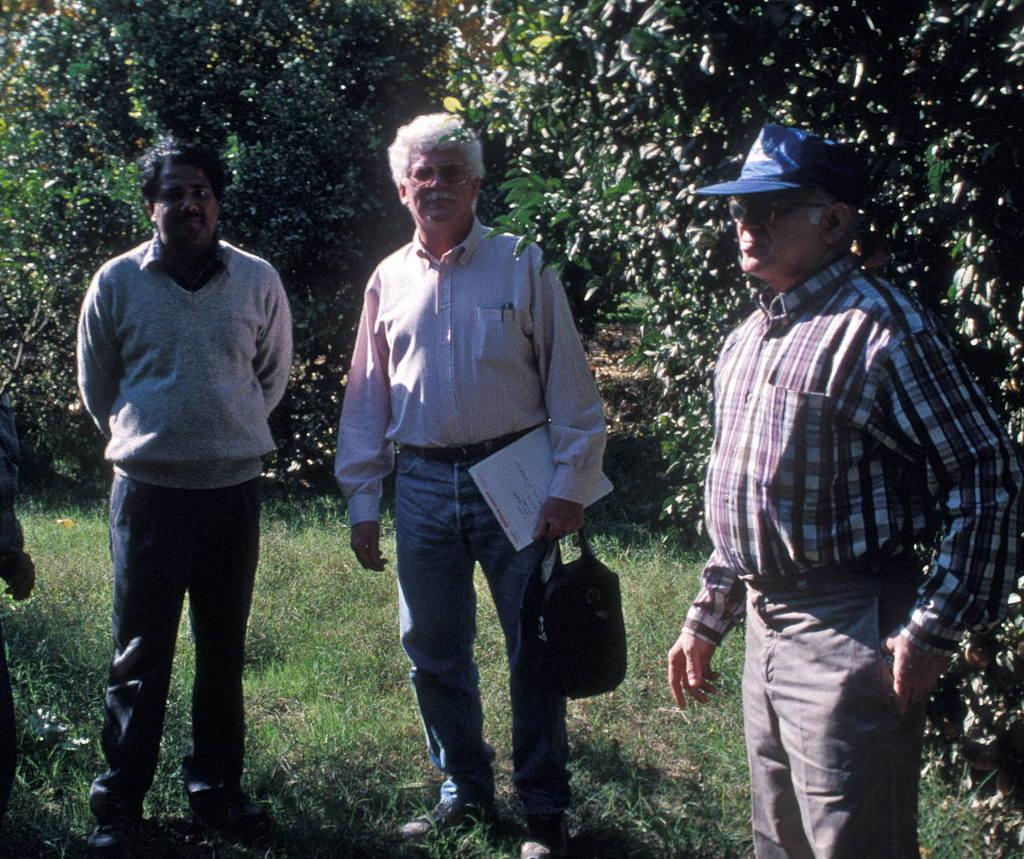Could you give a brief overview of what you see in this image? In the image there are three men standing on the grass and behind them there are some trees. 